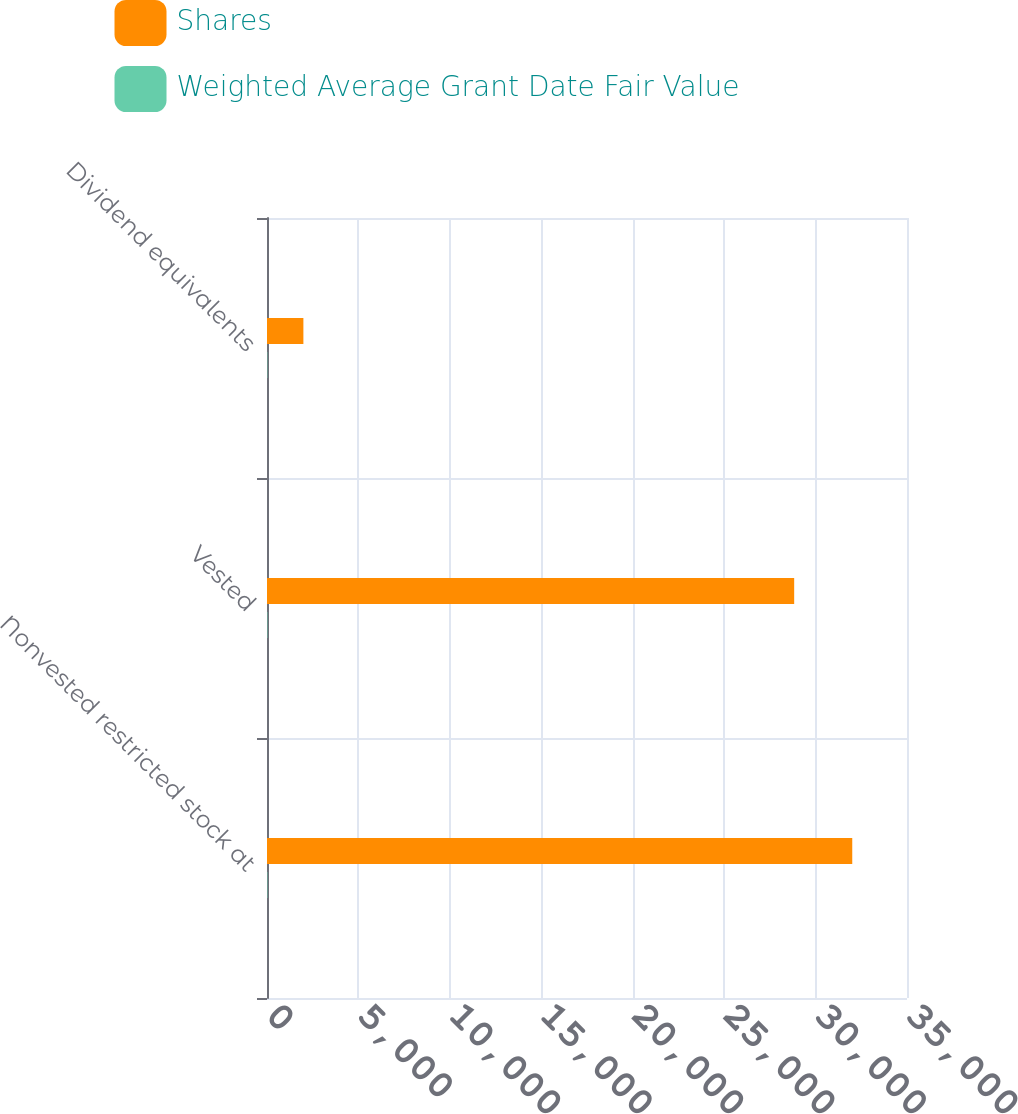Convert chart. <chart><loc_0><loc_0><loc_500><loc_500><stacked_bar_chart><ecel><fcel>Nonvested restricted stock at<fcel>Vested<fcel>Dividend equivalents<nl><fcel>Shares<fcel>32006<fcel>28830<fcel>1990<nl><fcel>Weighted Average Grant Date Fair Value<fcel>21.77<fcel>22.16<fcel>18.68<nl></chart> 